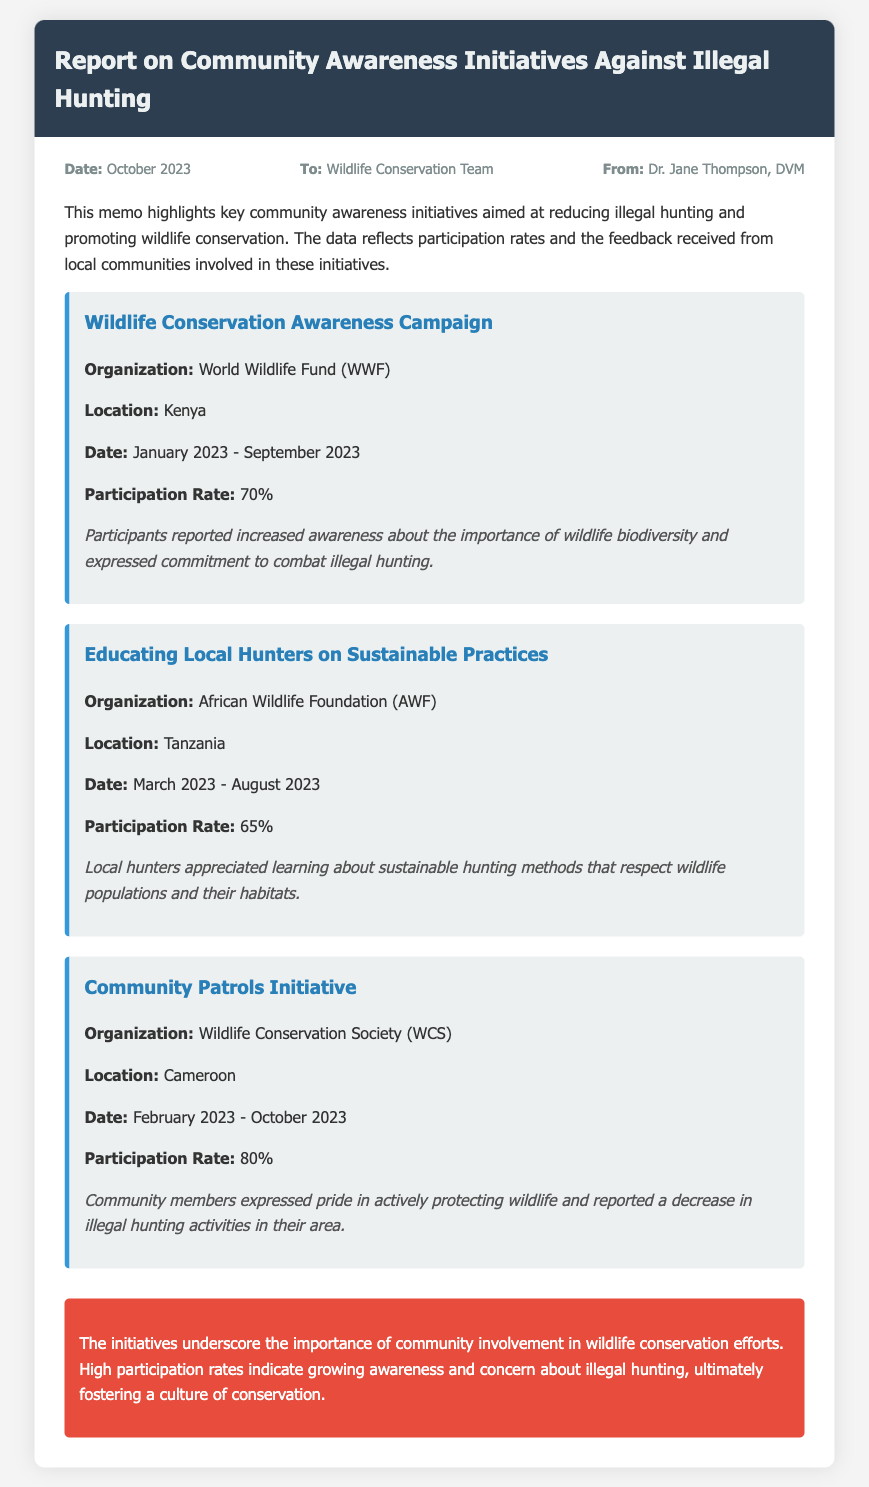what is the date of the report? The date of the report is stated at the top of the memo, which is October 2023.
Answer: October 2023 who is the sender of the memo? The sender of the memo is indicated in the meta section, which lists Dr. Jane Thompson, DVM.
Answer: Dr. Jane Thompson, DVM what is the participation rate of the Community Patrols Initiative? The participation rate for the Community Patrols Initiative is explicitly listed in the initiative section.
Answer: 80% which organization conducted the Educating Local Hunters on Sustainable Practices? The organization responsible for this initiative is mentioned directly within the initiative details.
Answer: African Wildlife Foundation (AWF) what feedback did participants give for the Wildlife Conservation Awareness Campaign? The feedback from participants is summarized and located in the section detailing this initiative.
Answer: Increased awareness about the importance of wildlife biodiversity and expressed commitment to combat illegal hunting compare the participation rates of the Wildlife Conservation Awareness Campaign and Educating Local Hunters on Sustainable Practices The memo provides specific participation rates for these initiatives, allowing for direct comparison.
Answer: 70% vs. 65% which initiative had the highest participation rate? The highest participation rate is found in the initiative descriptions.
Answer: Community Patrols Initiative what is the main conclusion of the memo? The conclusion summarizes the overall message conveyed in the memo regarding community involvement in conservation.
Answer: Importance of community involvement in wildlife conservation efforts 